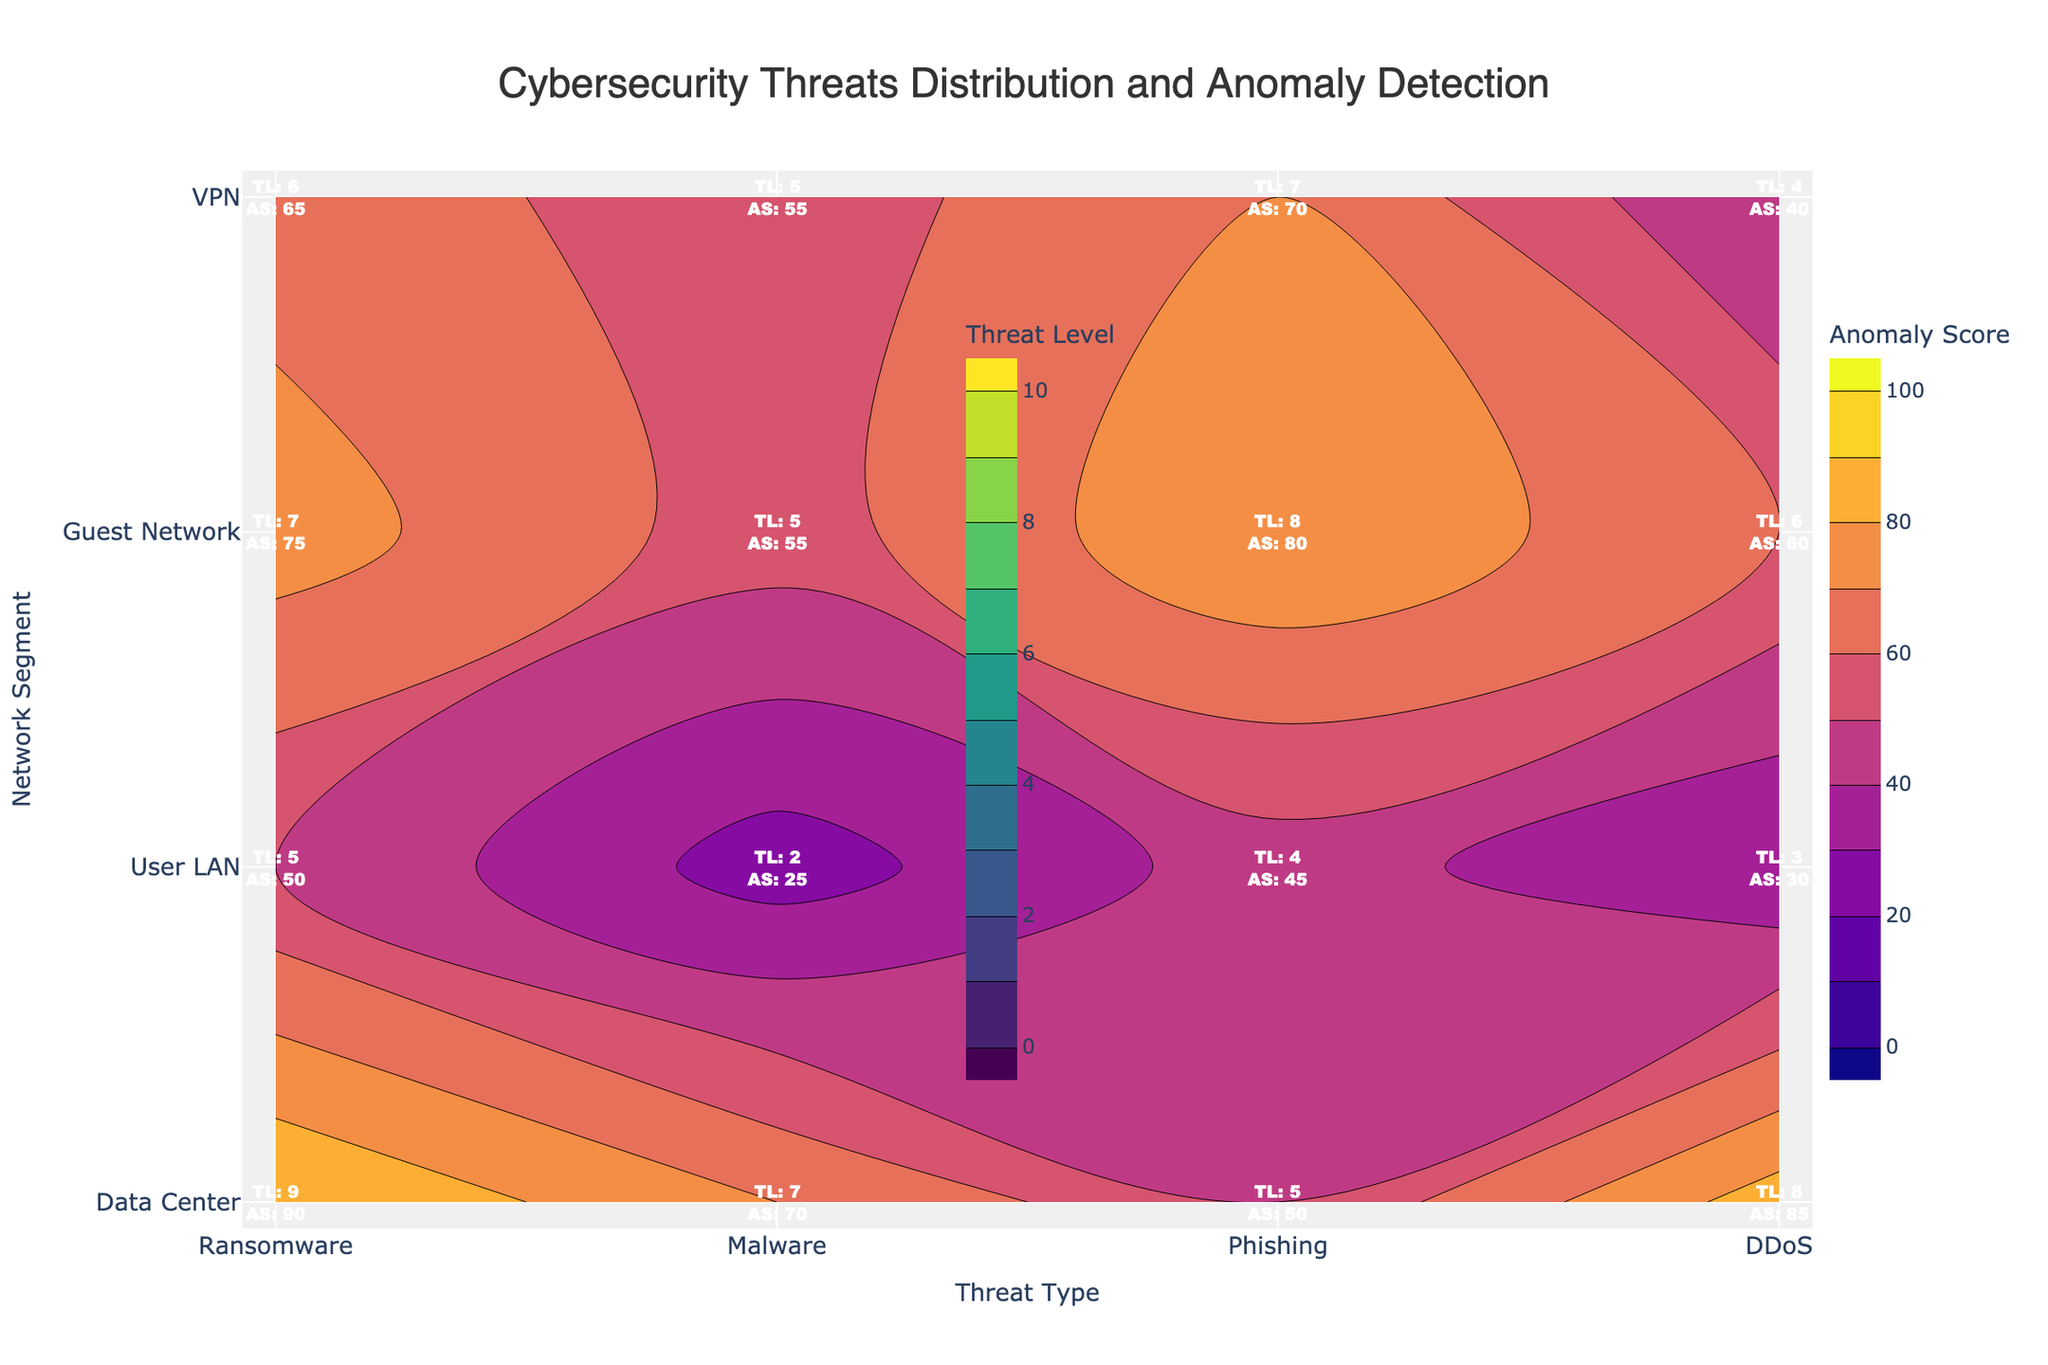How many network segments are displayed in the plot? There are unique segments represented on the y-axis of the contour plot. The segments listed are 'Data Center', 'User LAN', 'Guest Network', and 'VPN'.
Answer: 4 What is the highest threat level for 'Phishing' across all network segments? The contour plot labels indicate that 'Phishing' has its highest threat level in the 'User LAN' segment, which is 8.
Answer: 8 Which network segment has the lowest anomaly score for 'Malware'? According to the anomaly scores shown next to each threat type, the 'Guest Network' has the lowest anomaly score for 'Malware', which is 25.
Answer: Guest Network Compare the anomaly scores of 'DDoS' and 'Ransomware' in the 'VPN' segment. Which one is higher? By examining the contour labels in the 'VPN' segment, the anomaly score for 'DDoS' is 65 and for 'Ransomware' is 40. Thus, the anomaly score for 'DDoS' is higher.
Answer: DDoS What is the average threat level for all threat types in the 'Data Center' segment? The threat levels for 'Data Center' are 8 (Ransomware), 7 (Malware), 5 (Phishing), and 9 (DDoS). Summing these gives 8 + 7 + 5 + 9 = 29. The average threat level is 29 / 4 = 7.25.
Answer: 7.25 Which threat type has the most consistent threat level across all network segments? To determine the consistency, we look at the variance in threat levels across segments for each threat type. 'Malware' has the threat levels of 7 (Data Center), 5 (User LAN), 2 (Guest Network), and 5 (VPN), showing relatively smaller variance compared to others.
Answer: Malware Identify the network segment and threat type with the highest anomaly score. The highest anomaly score across all annotations is 90, which is found in the 'Data Center' segment for 'DDoS'.
Answer: Data Center, DDoS Is the anomaly score for 'Ransomware' in the 'User LAN' segment higher or lower than the average anomaly score of 'Ransomware' across all segments? Anomaly scores for 'Ransomware': 85 (Data Center), 60 (User LAN), 30 (Guest Network), 40 (VPN). Average score = (85 + 60 + 30 + 40) / 4 = 53.75. Anomaly score in 'User LAN' is 60, which is higher than the average.
Answer: Higher 